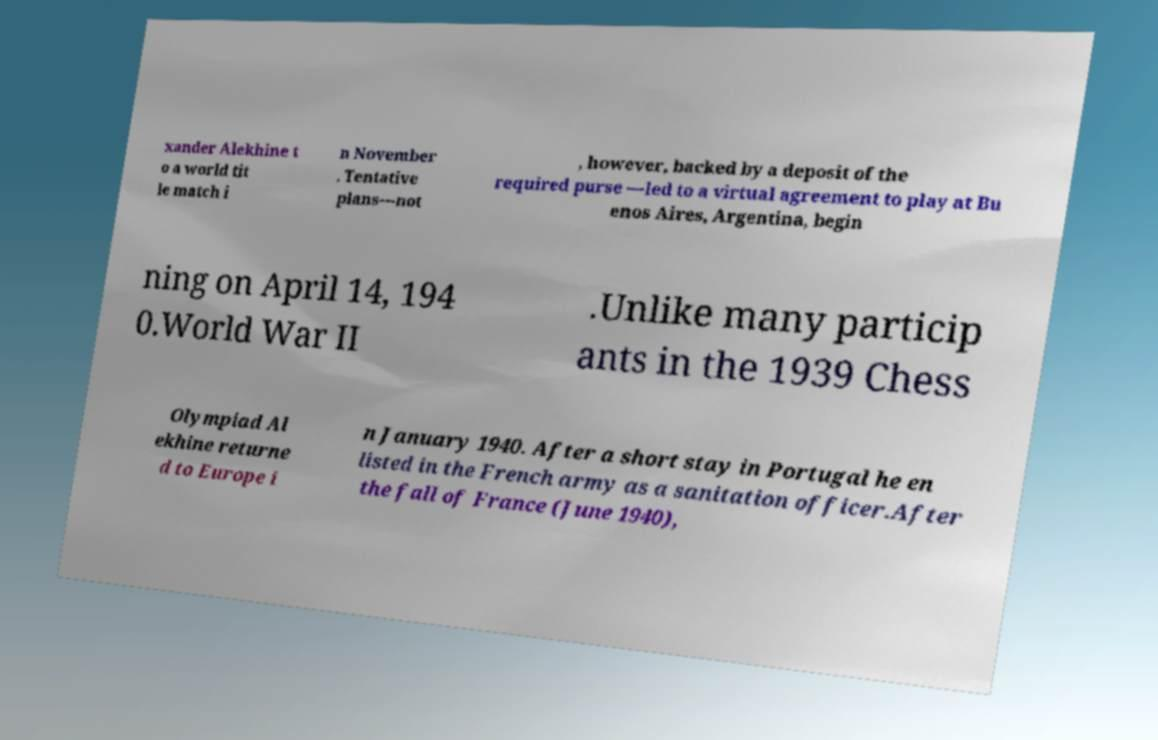Could you assist in decoding the text presented in this image and type it out clearly? xander Alekhine t o a world tit le match i n November . Tentative plans—not , however, backed by a deposit of the required purse —led to a virtual agreement to play at Bu enos Aires, Argentina, begin ning on April 14, 194 0.World War II .Unlike many particip ants in the 1939 Chess Olympiad Al ekhine returne d to Europe i n January 1940. After a short stay in Portugal he en listed in the French army as a sanitation officer.After the fall of France (June 1940), 